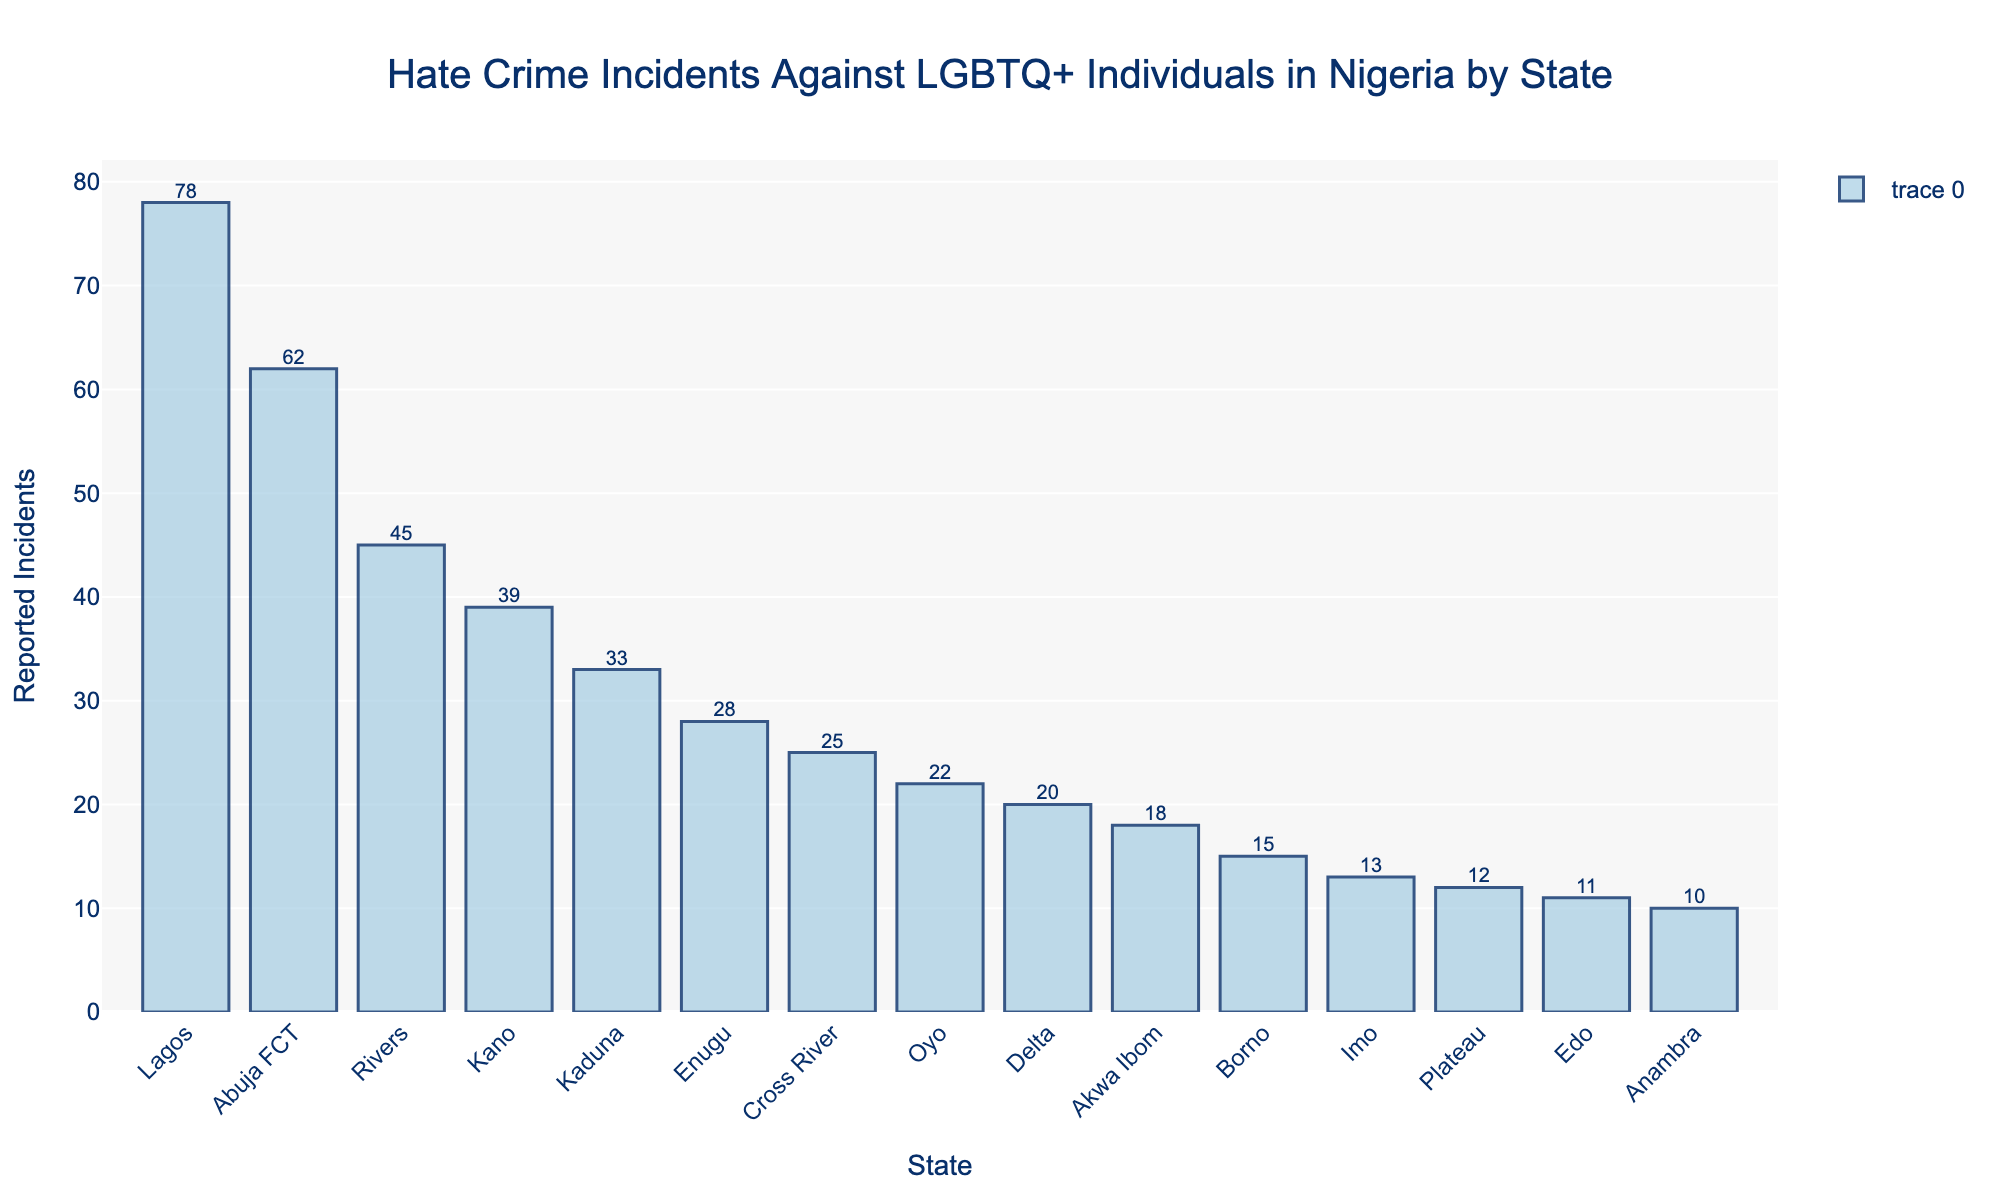Which state had the highest number of reported incidents? Look for the state with the longest bar to determine the highest number of reported incidents. Lagos has the longest bar.
Answer: Lagos Which state had the least number of reported incidents? Look for the state with the shortest bar to determine the least number of reported incidents. Anambra has the shortest bar.
Answer: Anambra What is the total number of reported incidents in the top three states combined? Add the number of reported incidents in the top three states (Lagos, Abuja FCT, Rivers): 78 + 62 + 45 = 185
Answer: 185 How many more reported incidents did Lagos have compared to Enugu? Subtract the number of reported incidents in Enugu from Lagos: 78 - 28 = 50
Answer: 50 Which state has a greater number of reported incidents: Kaduna or Kano? Compare the heights of the bars for Kaduna and Kano. Kano has a taller bar than Kaduna.
Answer: Kano What is the average number of reported incidents across all states? Sum all reported incidents (78 + 62 + 45 + 39 + 33 + 28 + 25 + 22 + 20 + 18 + 15 + 13 + 12 + 11 + 10 = 421) and divide by the number of states (15): 421 / 15 ≈ 28.07
Answer: 28.07 How many states have less than 20 reported incidents? Count the number of states with bars shorter than the bar representing 20 incidents. There are 8 states: Akwa Ibom, Borno, Imo, Plateau, Edo, Anambra.
Answer: 8 What is the difference in reported incidents between Cross River and Delta? Subtract the number of reported incidents in Delta from Cross River: 25 - 20 = 5
Answer: 5 Is the number of reported incidents in Rivers greater than the sum of those in Plateau and Imo combined? Calculate the sum of reported incidents in Plateau and Imo: 12 + 13 = 25, then compare with Rivers' 45. 45 is greater.
Answer: Yes What is the median number of reported incidents among the states? Arrange the sorted list of reported incidents: (10, 11, 12, 13, 15, 18, 20, 22, 25, 28, 33, 39, 45, 62, 78). The median is the middle value: 22.
Answer: 22 